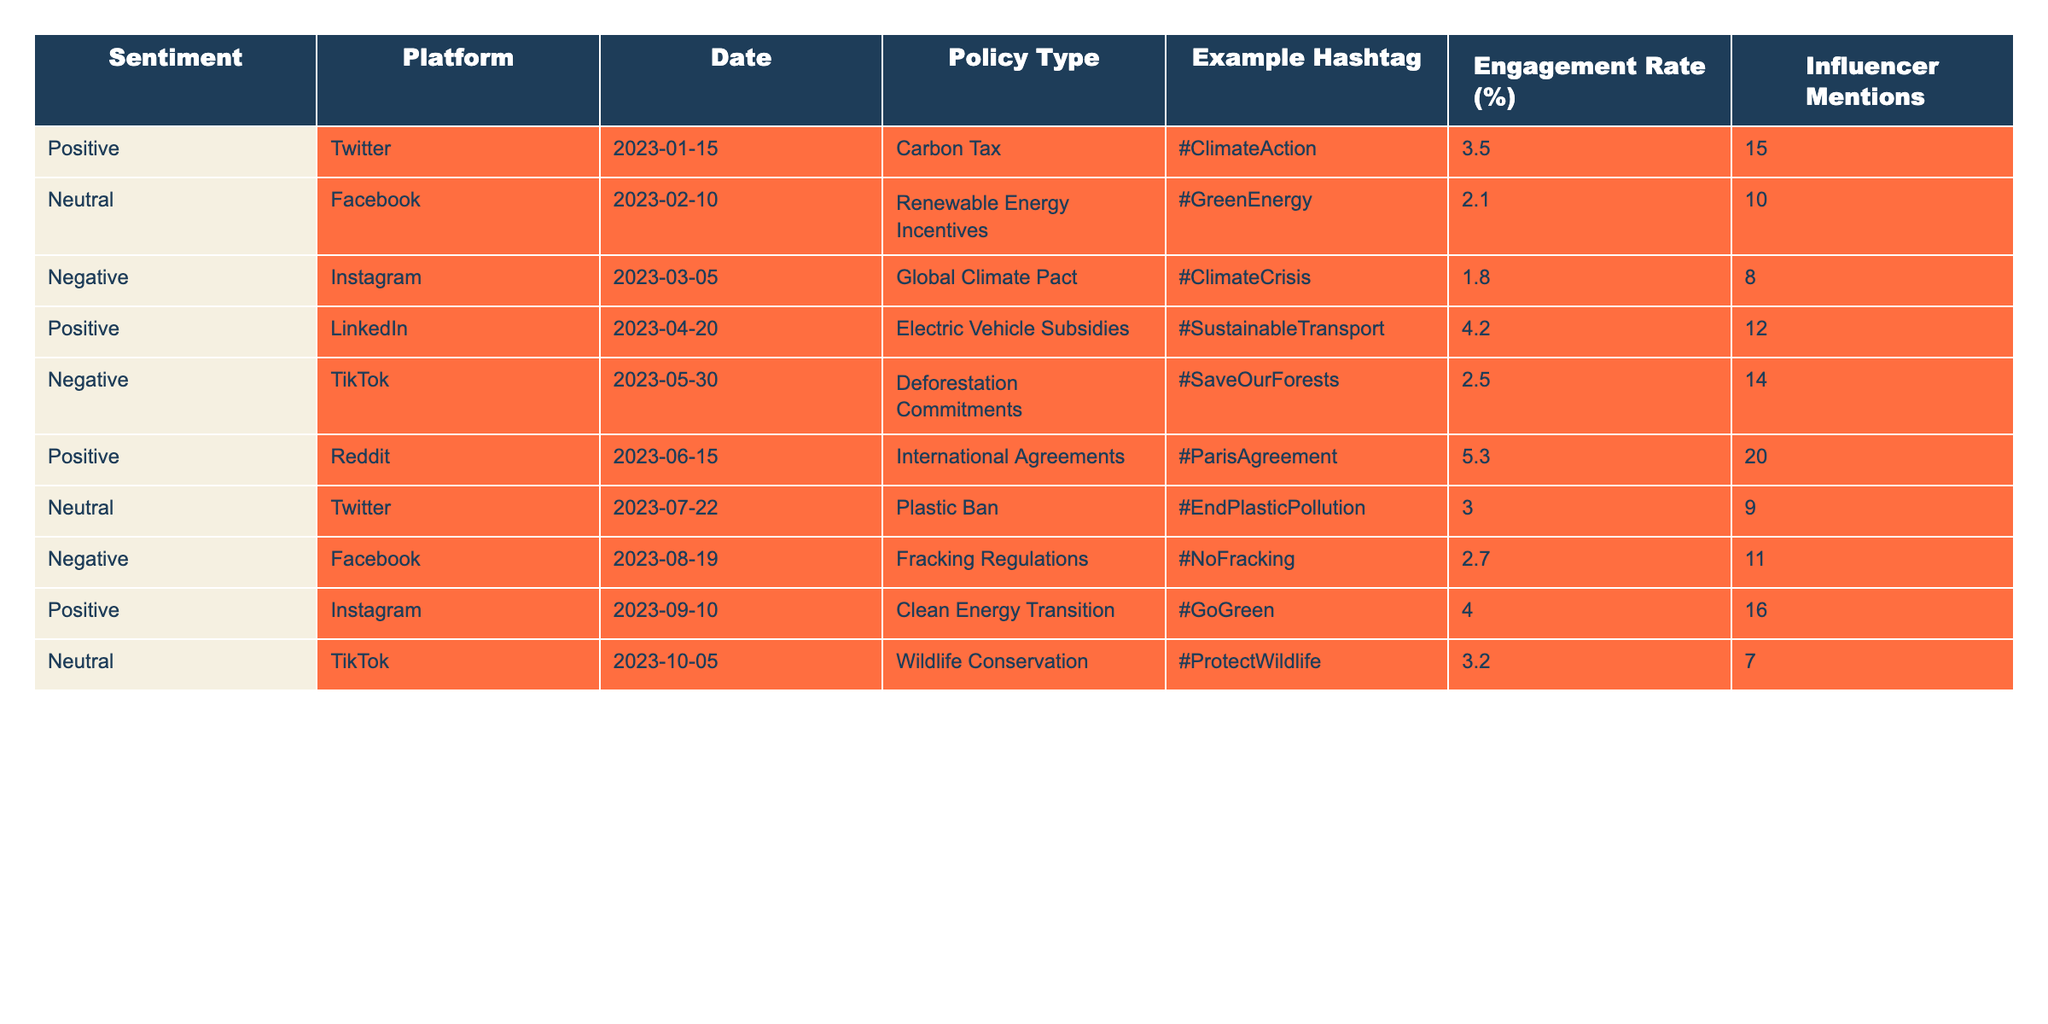What is the engagement rate for the post about Carbon Tax on Twitter? The table specifies the engagement rate for the Carbon Tax post on Twitter as 3.5%.
Answer: 3.5% How many influencer mentions were associated with the Deforestation Commitments on TikTok? The table indicates that there were 14 influencer mentions for the Deforestation Commitments post on TikTok.
Answer: 14 What type of sentiment was observed for the Plastic Ban on Twitter? The table shows that the sentiment for the Plastic Ban post on Twitter was Neutral.
Answer: Neutral Which policy type had the highest engagement rate in the table? Reviewing the engagement rates, the International Agreements on Reddit had the highest rate at 5.3%.
Answer: International Agreements How many more influencer mentions did the post about Electric Vehicle Subsidies have compared to the post about Clean Energy Transition? The Electric Vehicle Subsidies post had 12 mentions and the Clean Energy Transition post had 16 mentions. The difference is 16 - 12 = 4.
Answer: 4 Is the sentiment for Wildlife Conservation on TikTok positive? The table states that the sentiment for Wildlife Conservation on TikTok is Neutral, so it is not positive.
Answer: No What is the average engagement rate for all posts in the table? Adding all engagement rates: (3.5 + 2.1 + 1.8 + 4.2 + 2.5 + 5.3 + 3.0 + 2.7 + 4.0 + 3.2) = 28.3 and dividing by 10 gives an average of 2.83.
Answer: 2.83 Which platform had the most negative sentiment overall? The table indicates that Instagram for the Global Climate Pact and TikTok for Deforestation Commitments both have Negative sentiment, but among them, TikTok has the more recent negative sentiment; thus, I consider it the most recent negative sentiment.
Answer: TikTok How many posts received a positive sentiment and involved the policy type of Renewable Energy Incentives? The table shows that the Renewable Energy Incentives post had Neutral sentiment, so it received no positive sentiment.
Answer: 0 What is the total number of influencer mentions from all the Positive posts in the table? The influencer mentions for Positive posts: Carbon Tax (15), Electric Vehicle Subsidies (12), International Agreements (20), and Clean Energy Transition (16). Adding these gives 15 + 12 + 20 + 16 = 63.
Answer: 63 